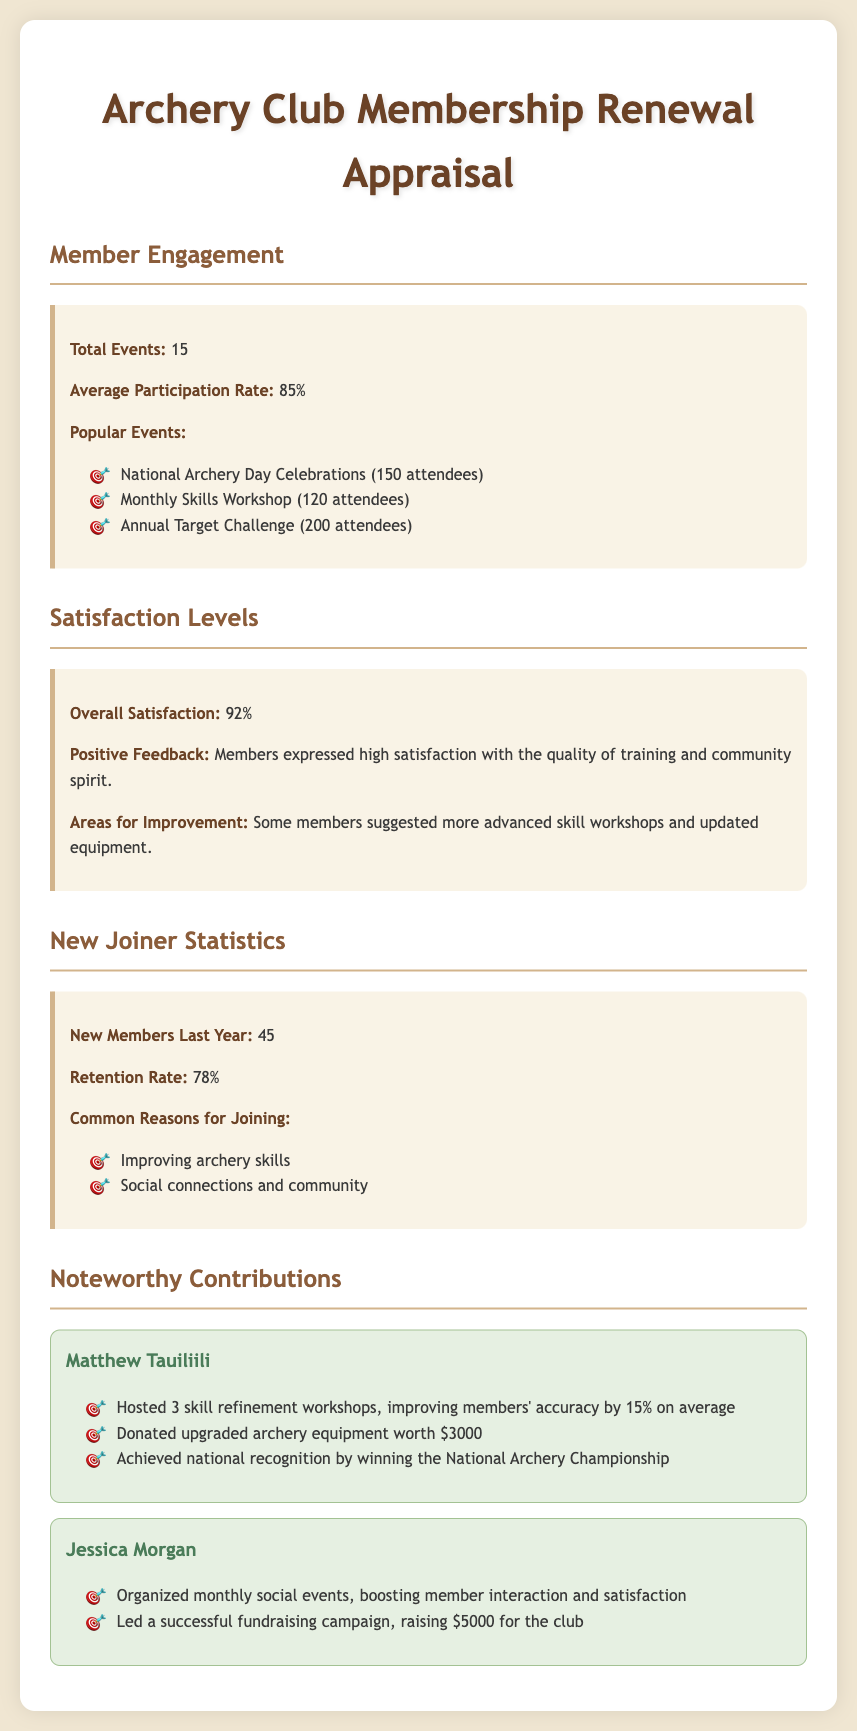What is the total number of events held? The total number of events is explicitly mentioned in the document under the Member Engagement section.
Answer: 15 What is the average participation rate? The average participation rate is noted in the Member Engagement section, directly indicating engagement levels among members.
Answer: 85% What was the overall satisfaction percentage? The overall satisfaction percentage is provided under the Satisfaction Levels section, summarizing member satisfaction.
Answer: 92% How many new members joined last year? The number of new members is specified in the New Joiner Statistics section, reflecting recruitment efforts of the club.
Answer: 45 What is the retention rate of members? The retention rate is listed in the New Joiner Statistics section, indicating the club's ability to keep its members.
Answer: 78% Which prominent member hosted skill refinement workshops? The document highlights Matthew Tauiliili as the member who hosted skill refinement workshops, contributing to skill improvement.
Answer: Matthew Tauiliili How much did Matthew Tauiliili donate in upgraded equipment? The donation amount made by Matthew Tauiliili is indicated in the Noteworthy Contributions section, showcasing his commitment to the club.
Answer: $3000 What is one common reason for joining the club? The common reasons for joining are outlined in the New Joiner Statistics section, summarizing member motivations.
Answer: Improving archery skills Which event had the highest attendance? The event with highest attendance is mentioned in the Member Engagement section, providing insight into popular activities.
Answer: Annual Target Challenge 